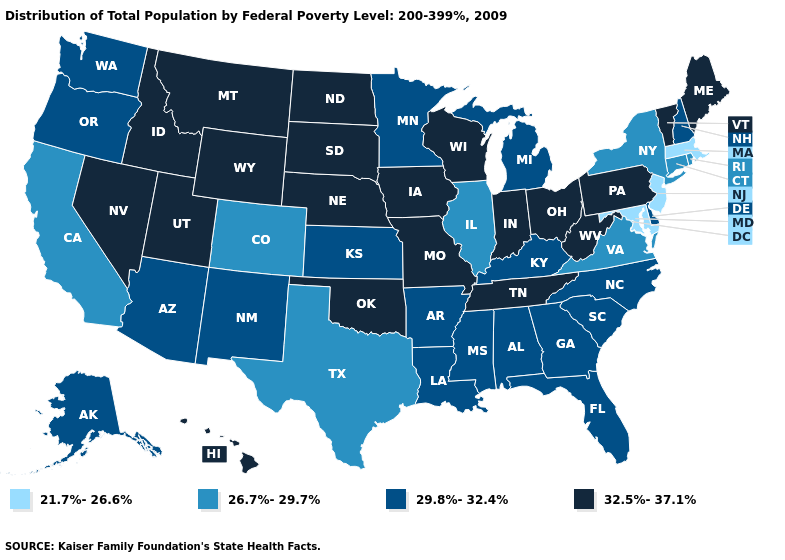Name the states that have a value in the range 32.5%-37.1%?
Short answer required. Hawaii, Idaho, Indiana, Iowa, Maine, Missouri, Montana, Nebraska, Nevada, North Dakota, Ohio, Oklahoma, Pennsylvania, South Dakota, Tennessee, Utah, Vermont, West Virginia, Wisconsin, Wyoming. Does Massachusetts have a higher value than Kansas?
Give a very brief answer. No. Name the states that have a value in the range 26.7%-29.7%?
Keep it brief. California, Colorado, Connecticut, Illinois, New York, Rhode Island, Texas, Virginia. Among the states that border Indiana , does Illinois have the lowest value?
Write a very short answer. Yes. What is the value of Ohio?
Quick response, please. 32.5%-37.1%. What is the lowest value in the USA?
Be succinct. 21.7%-26.6%. Is the legend a continuous bar?
Give a very brief answer. No. Among the states that border Wyoming , which have the lowest value?
Short answer required. Colorado. What is the lowest value in states that border Michigan?
Be succinct. 32.5%-37.1%. Name the states that have a value in the range 29.8%-32.4%?
Answer briefly. Alabama, Alaska, Arizona, Arkansas, Delaware, Florida, Georgia, Kansas, Kentucky, Louisiana, Michigan, Minnesota, Mississippi, New Hampshire, New Mexico, North Carolina, Oregon, South Carolina, Washington. Does the map have missing data?
Be succinct. No. Name the states that have a value in the range 26.7%-29.7%?
Quick response, please. California, Colorado, Connecticut, Illinois, New York, Rhode Island, Texas, Virginia. What is the value of Alabama?
Quick response, please. 29.8%-32.4%. What is the value of Maryland?
Concise answer only. 21.7%-26.6%. Name the states that have a value in the range 26.7%-29.7%?
Concise answer only. California, Colorado, Connecticut, Illinois, New York, Rhode Island, Texas, Virginia. 